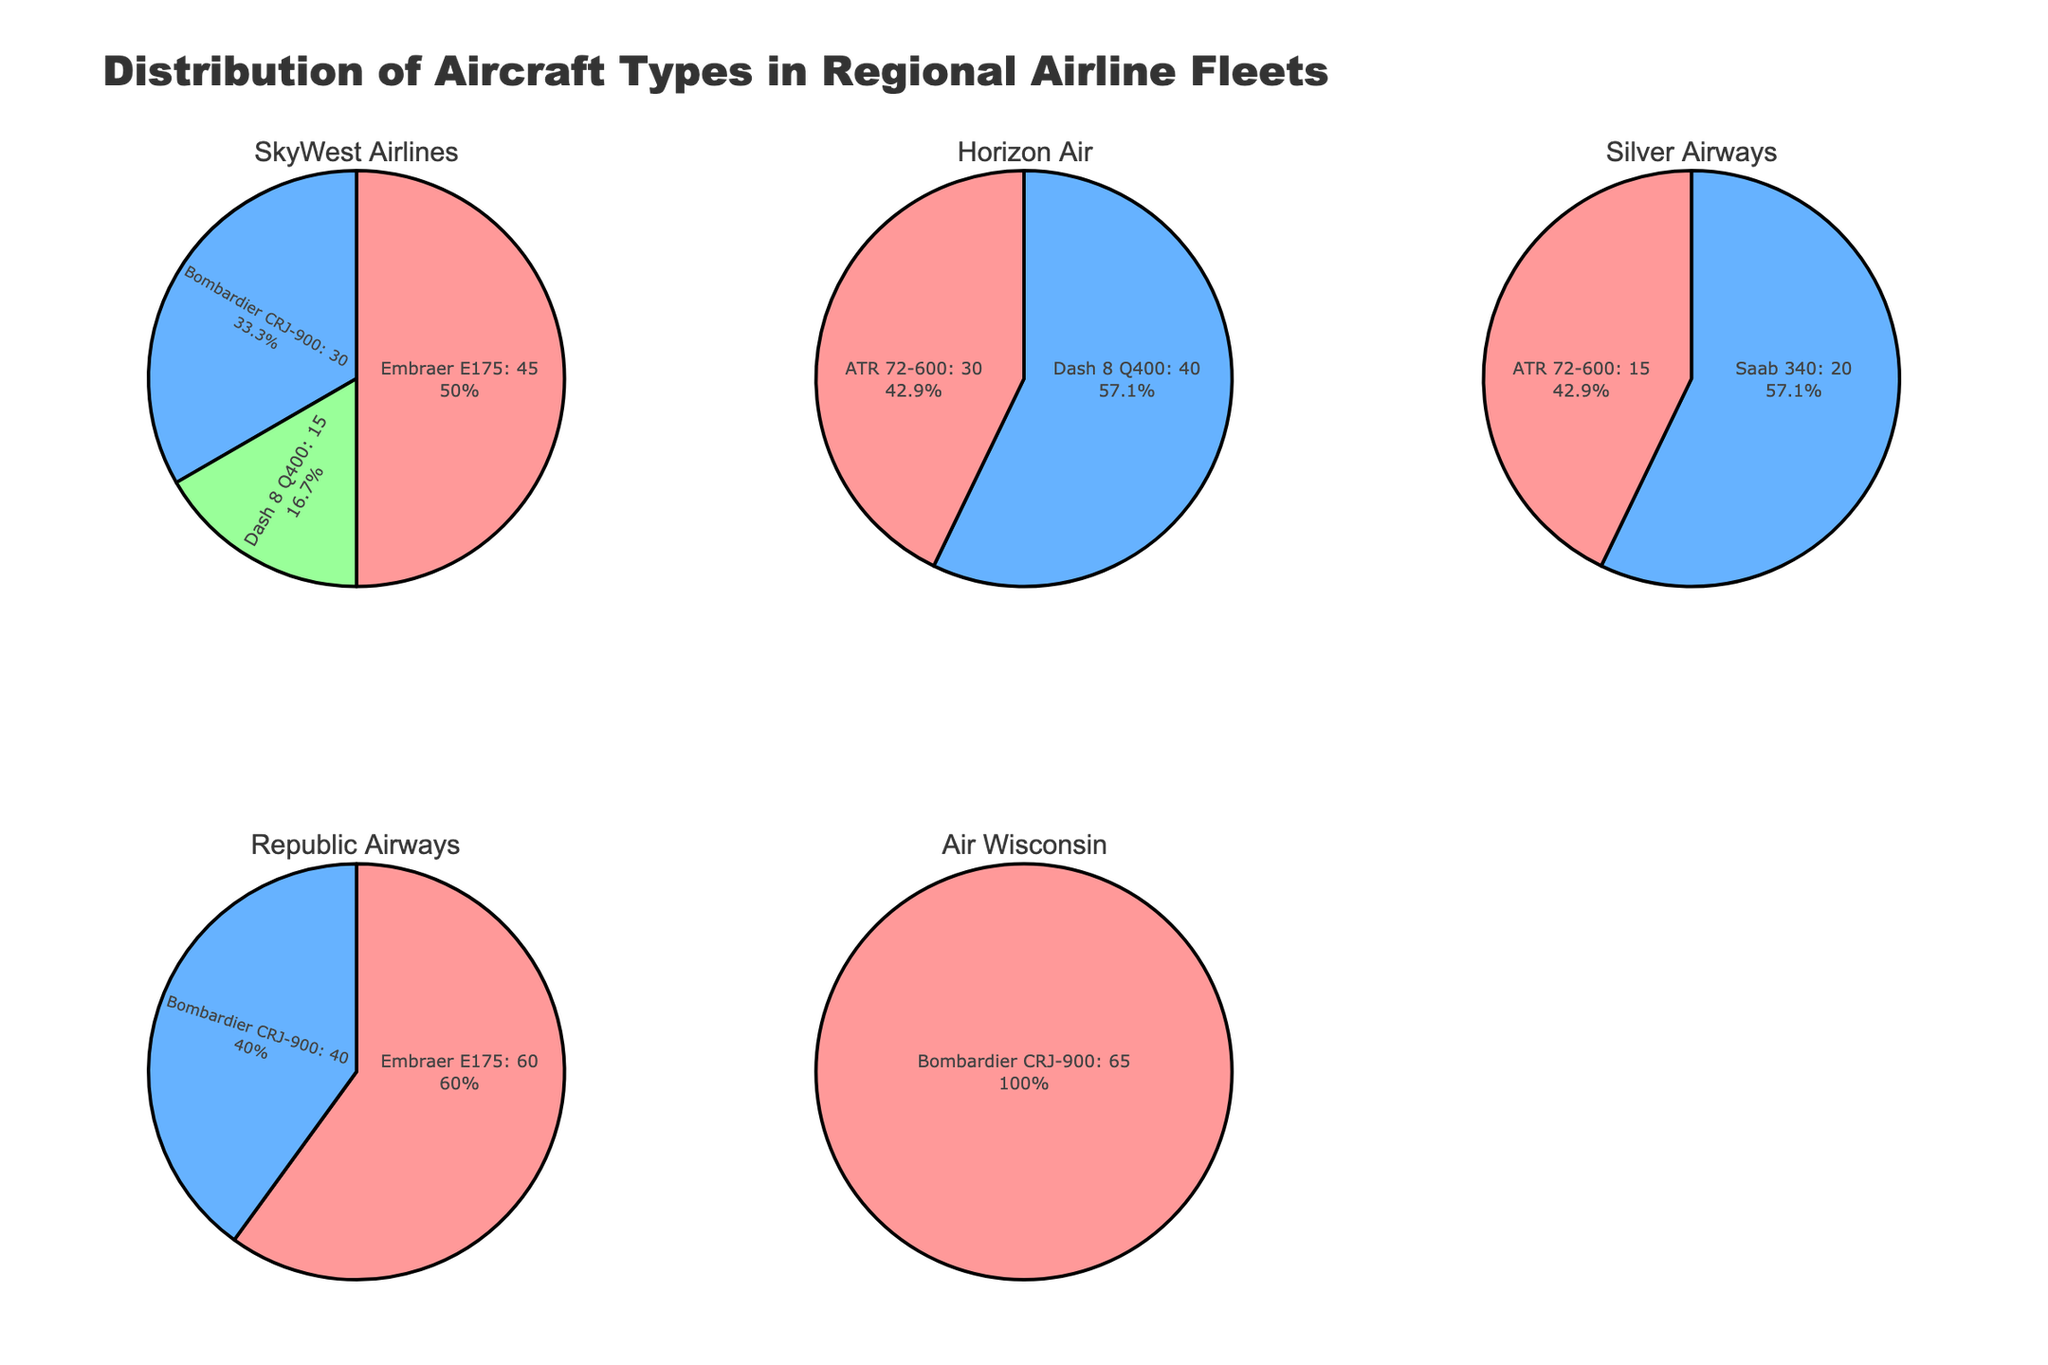What is the title of the figure? The title is displayed at the top of the figure, usually in larger and bold text. In this case, the title can be found at the center, and it reads "Distribution of Aircraft Types in Regional Airline Fleets."
Answer: Distribution of Aircraft Types in Regional Airline Fleets Which airline has the most varied fleet? To determine this, look at the number of different aircraft types each airline operates. SkyWest Airlines employs 4 distinct types: Embraer E175, Bombardier CRJ-900, Dash 8 Q400, and Saab 340. The other airlines operate fewer types.
Answer: SkyWest Airlines What percentage of Horizon Air's fleet is made up of Dash 8 Q400 aircraft? Reading the Horizon Air pie chart, Dash 8 Q400s make up 40 out of (30 + 40) = 70 total aircraft. The percentage is (40/70) * 100, which simplifies to about 57.14%.
Answer: 57.14% How many ATR 72-600 aircraft does Silver Airways operate? Looking at Silver Airways' pie chart, it shows that they operate 15 ATR 72-600 aircraft.
Answer: 15 Which airline operates the highest number of a single aircraft type? From the pie charts, Air Wisconsin operates the highest number of a single aircraft type with 65 Bombardier CRJ-900s.
Answer: Air Wisconsin Does Republic Airways operate any ATR 72-600s? The Republic Airways pie chart does not display any portion labeled as ATR 72-600, indicating they do not operate this type of aircraft.
Answer: No What fraction of SkyWest Airlines' fleet is made up of Bombardier CRJ-900 aircraft? SkyWest Airlines operates 30 Bombardier CRJ-900s out of a total of 90 aircraft (45+30+15). Thus, the fraction is 30/90 which simplifies to 1/3.
Answer: 1/3 Compare the number of Embraer E175 aircraft operated by SkyWest Airlines and Republic Airways. SkyWest Airlines operates 45 Embraer E175s and Republic Airways operates 60. Here, Republic Airways operates 15 more than SkyWest Airlines.
Answer: Republic Airways operates 15 more Which airline operates both Embraer E175 and Bombardier CRJ-900 aircraft? By looking at the pie charts, SkyWest Airlines is the only airline that operates both Embraer E175 and Bombardier CRJ-900 aircraft.
Answer: SkyWest Airlines 